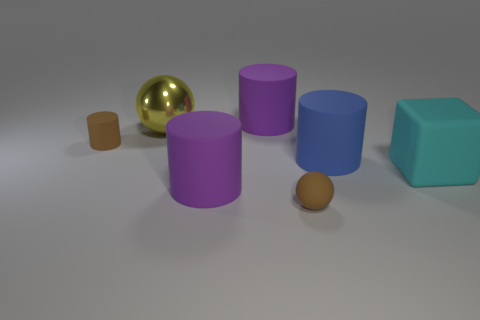Subtract all big cylinders. How many cylinders are left? 1 Subtract 1 cylinders. How many cylinders are left? 3 Subtract all blue cylinders. How many cylinders are left? 3 Add 2 tiny brown rubber cylinders. How many objects exist? 9 Subtract all gray cylinders. Subtract all cyan spheres. How many cylinders are left? 4 Subtract all spheres. How many objects are left? 5 Subtract all tiny brown shiny spheres. Subtract all yellow metallic things. How many objects are left? 6 Add 6 tiny brown matte cylinders. How many tiny brown matte cylinders are left? 7 Add 1 yellow matte balls. How many yellow matte balls exist? 1 Subtract 1 cyan blocks. How many objects are left? 6 